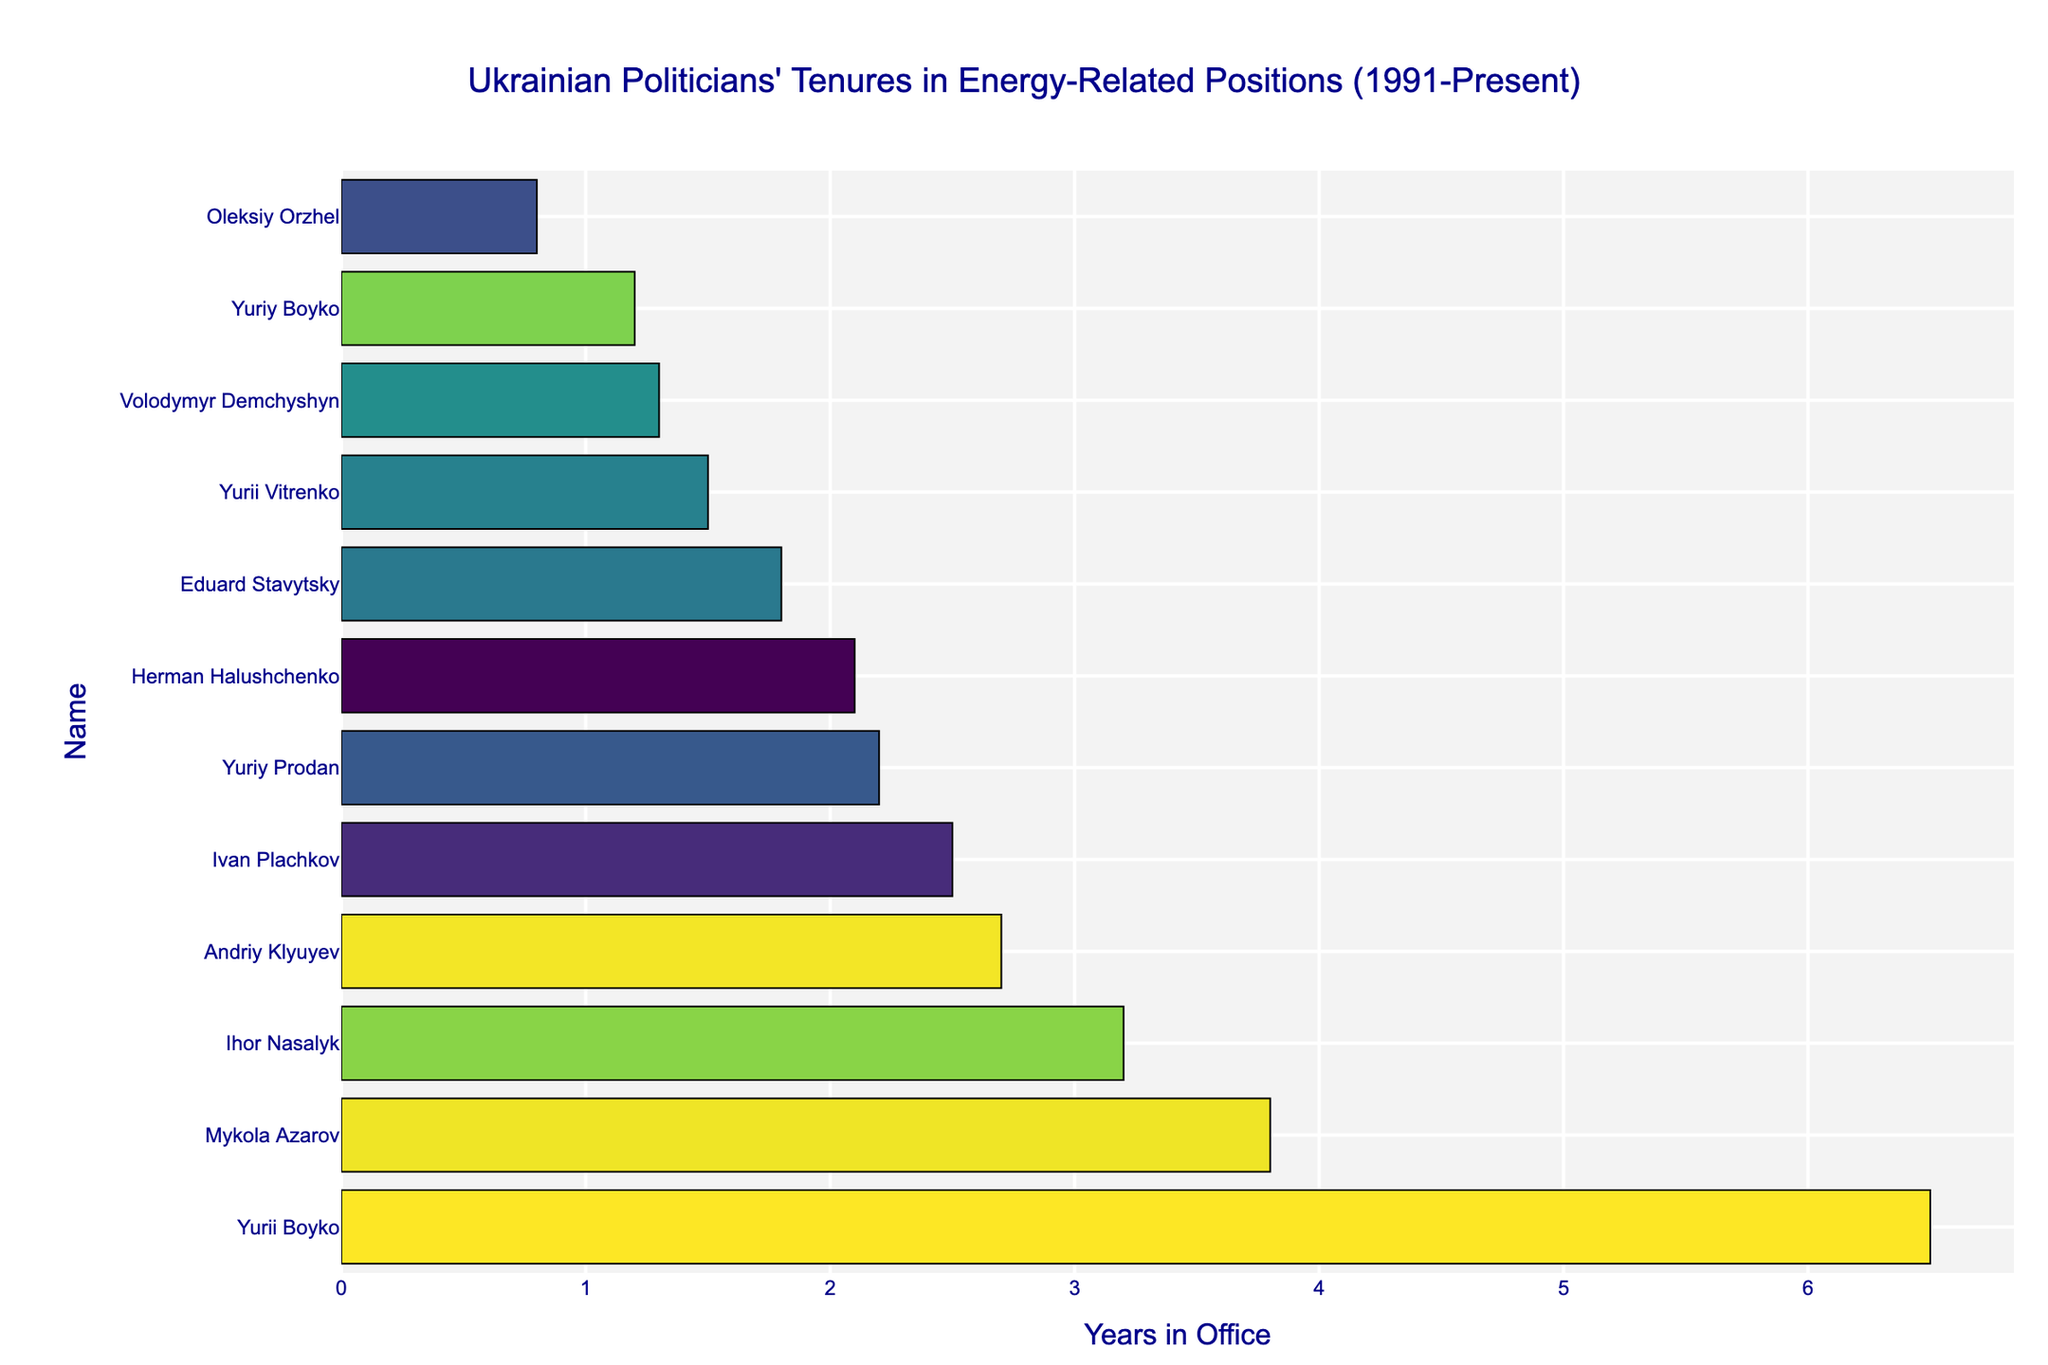Which politician had the longest tenure in an energy-related position? Look at the politician with the longest bar in the figure. The visualization shows Yurii Boyko as having the longest tenure.
Answer: Yurii Boyko Who served as the Minister of Fuel and Energy for 2.5 years? Identify the politician with a bar at 2.5 years and check the corresponding name. The politician is Ivan Plachkov.
Answer: Ivan Plachkov What is the combined tenure of the politicians who served under the position "Minister of Energy and Coal Industry"? Sum the lengths of the bars for Eduard Stavytsky (1.8), Volodymyr Demchyshyn (1.3), and Ihor Nasalyk (3.2). Total = 1.8 + 1.3 + 3.2 = 6.3 years.
Answer: 6.3 years Who had a longer tenure: Eduard Stavytsky or Yurii Vitrenko? Compare the lengths of the bars of Eduard Stavytsky (1.8 years) and Yurii Vitrenko (1.5 years). Eduard Stavytsky had a longer tenure.
Answer: Eduard Stavytsky Which politician's tenure as an energy-related minister is represented by the shortest bar? Identify the shortest bar in the figure. It corresponds to Oleksiy Orzhel with 0.8 years.
Answer: Oleksiy Orzhel How does the tenure of Mykola Azarov compare to Ihor Nasalyk? Look at the bars for Mykola Azarov (3.8 years) and Ihor Nasalyk (3.2 years). Mykola Azarov's bar is longer.
Answer: Mykola Azarov What is the average tenure of politicians listed as "Minister of Fuel and Energy"? Ian Plachkov (2.5), Yuriy Prodan (2.2), and Yurii Boyko (6.5). Sum = 2.5 + 2.2 + 6.5 = 11.2; number of values = 3; average = 11.2 / 3 = 3.73 (rounded to 2 decimal places).
Answer: 3.73 years Who served for 1.3 years as "Minister of Energy and Coal Industry"? Check the bar corresponding to 1.3 years under this position. The politician is Volodymyr Demchyshyn.
Answer: Volodymyr Demchyshyn What is the total tenure of all politicians shown in the figure? Sum the lengths of all bars: 6.5 + 2.5 + 2.2 + 1.8 + 1.3 + 3.2 + 0.8 + 1.5 + 2.1 + 1.2 + 2.7 + 3.8 = 29.6 years.
Answer: 29.6 years 